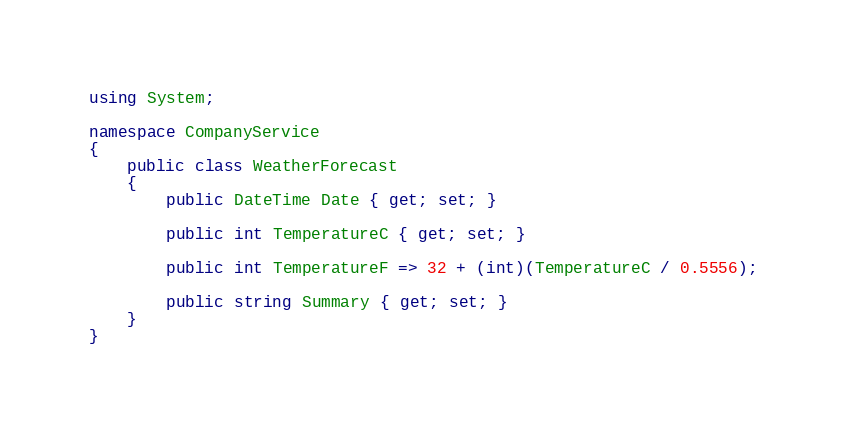<code> <loc_0><loc_0><loc_500><loc_500><_C#_>using System;

namespace CompanyService
{
    public class WeatherForecast
    {
        public DateTime Date { get; set; }

        public int TemperatureC { get; set; }

        public int TemperatureF => 32 + (int)(TemperatureC / 0.5556);

        public string Summary { get; set; }
    }
}
</code> 